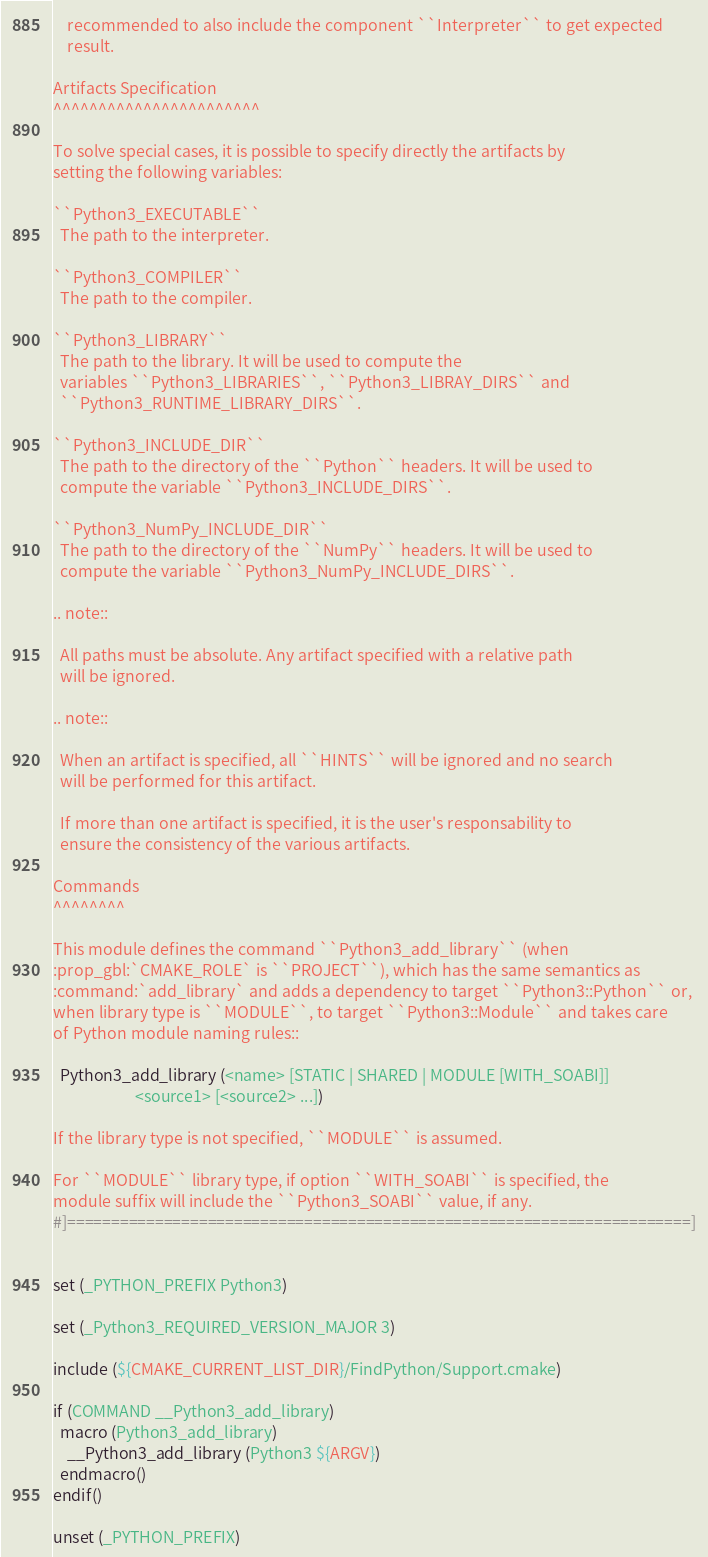Convert code to text. <code><loc_0><loc_0><loc_500><loc_500><_CMake_>    recommended to also include the component ``Interpreter`` to get expected
    result.

Artifacts Specification
^^^^^^^^^^^^^^^^^^^^^^^

To solve special cases, it is possible to specify directly the artifacts by
setting the following variables:

``Python3_EXECUTABLE``
  The path to the interpreter.

``Python3_COMPILER``
  The path to the compiler.

``Python3_LIBRARY``
  The path to the library. It will be used to compute the
  variables ``Python3_LIBRARIES``, ``Python3_LIBRAY_DIRS`` and
  ``Python3_RUNTIME_LIBRARY_DIRS``.

``Python3_INCLUDE_DIR``
  The path to the directory of the ``Python`` headers. It will be used to
  compute the variable ``Python3_INCLUDE_DIRS``.

``Python3_NumPy_INCLUDE_DIR``
  The path to the directory of the ``NumPy`` headers. It will be used to
  compute the variable ``Python3_NumPy_INCLUDE_DIRS``.

.. note::

  All paths must be absolute. Any artifact specified with a relative path
  will be ignored.

.. note::

  When an artifact is specified, all ``HINTS`` will be ignored and no search
  will be performed for this artifact.

  If more than one artifact is specified, it is the user's responsability to
  ensure the consistency of the various artifacts.

Commands
^^^^^^^^

This module defines the command ``Python3_add_library`` (when
:prop_gbl:`CMAKE_ROLE` is ``PROJECT``), which has the same semantics as
:command:`add_library` and adds a dependency to target ``Python3::Python`` or,
when library type is ``MODULE``, to target ``Python3::Module`` and takes care
of Python module naming rules::

  Python3_add_library (<name> [STATIC | SHARED | MODULE [WITH_SOABI]]
                       <source1> [<source2> ...])

If the library type is not specified, ``MODULE`` is assumed.

For ``MODULE`` library type, if option ``WITH_SOABI`` is specified, the
module suffix will include the ``Python3_SOABI`` value, if any.
#]=======================================================================]


set (_PYTHON_PREFIX Python3)

set (_Python3_REQUIRED_VERSION_MAJOR 3)

include (${CMAKE_CURRENT_LIST_DIR}/FindPython/Support.cmake)

if (COMMAND __Python3_add_library)
  macro (Python3_add_library)
    __Python3_add_library (Python3 ${ARGV})
  endmacro()
endif()

unset (_PYTHON_PREFIX)
</code> 